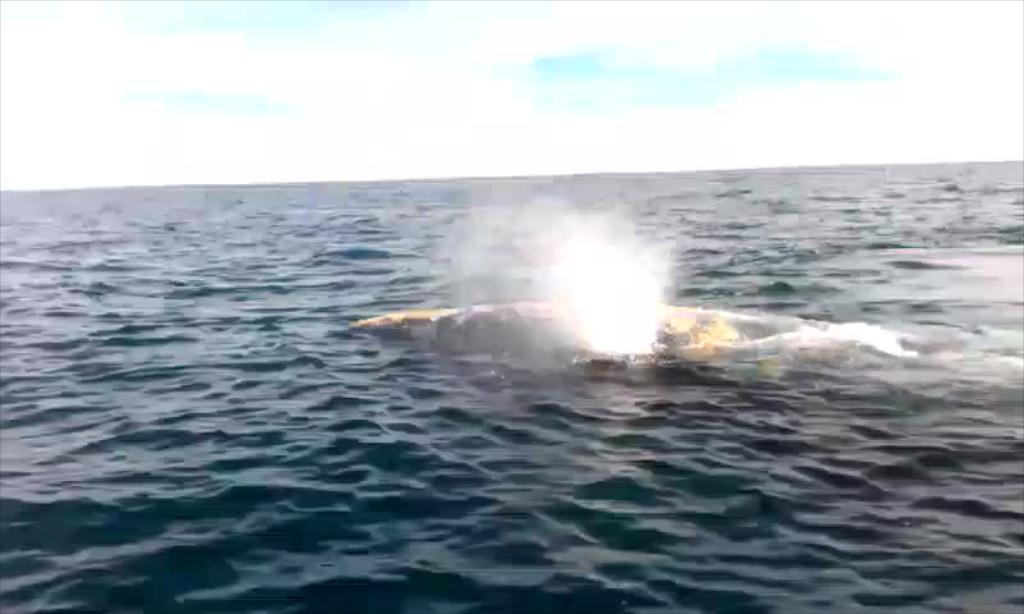Can you describe this image briefly? This picture is clicked outside the city. In the center there is an object in the water body. In the background there is a sky. 